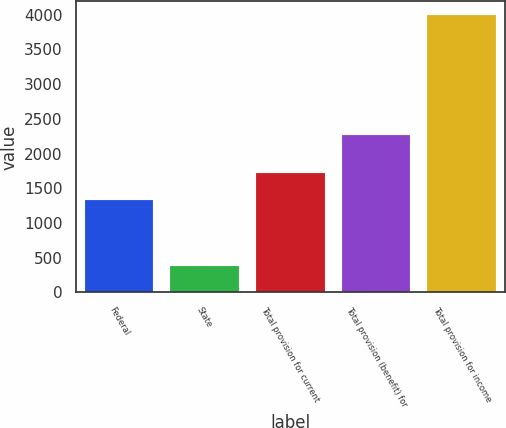Convert chart. <chart><loc_0><loc_0><loc_500><loc_500><bar_chart><fcel>Federal<fcel>State<fcel>Total provision for current<fcel>Total provision (benefit) for<fcel>Total provision for income<nl><fcel>1330<fcel>388<fcel>1718<fcel>2275<fcel>3993<nl></chart> 